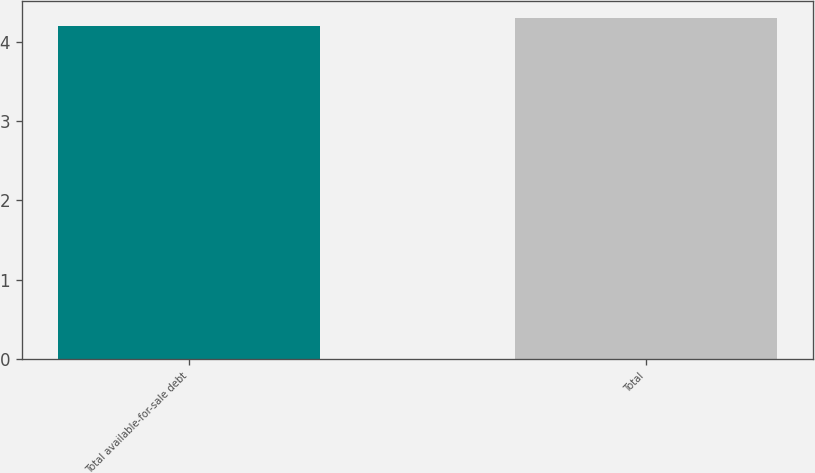Convert chart. <chart><loc_0><loc_0><loc_500><loc_500><bar_chart><fcel>Total available-for-sale debt<fcel>Total<nl><fcel>4.2<fcel>4.3<nl></chart> 